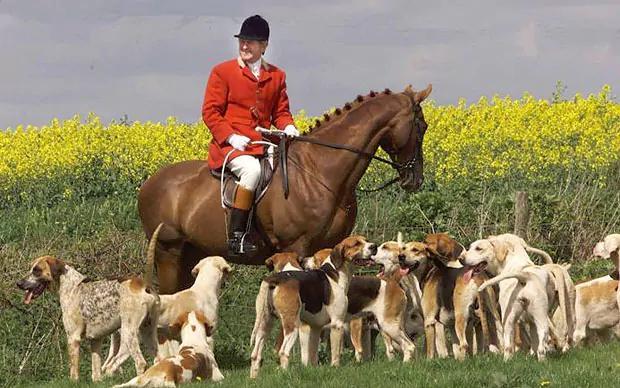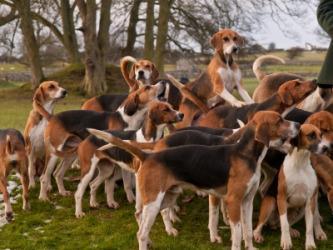The first image is the image on the left, the second image is the image on the right. Assess this claim about the two images: "A persons leg is visible in the right image.". Correct or not? Answer yes or no. No. The first image is the image on the left, the second image is the image on the right. Considering the images on both sides, is "In one image, all dogs are running in a field." valid? Answer yes or no. No. 